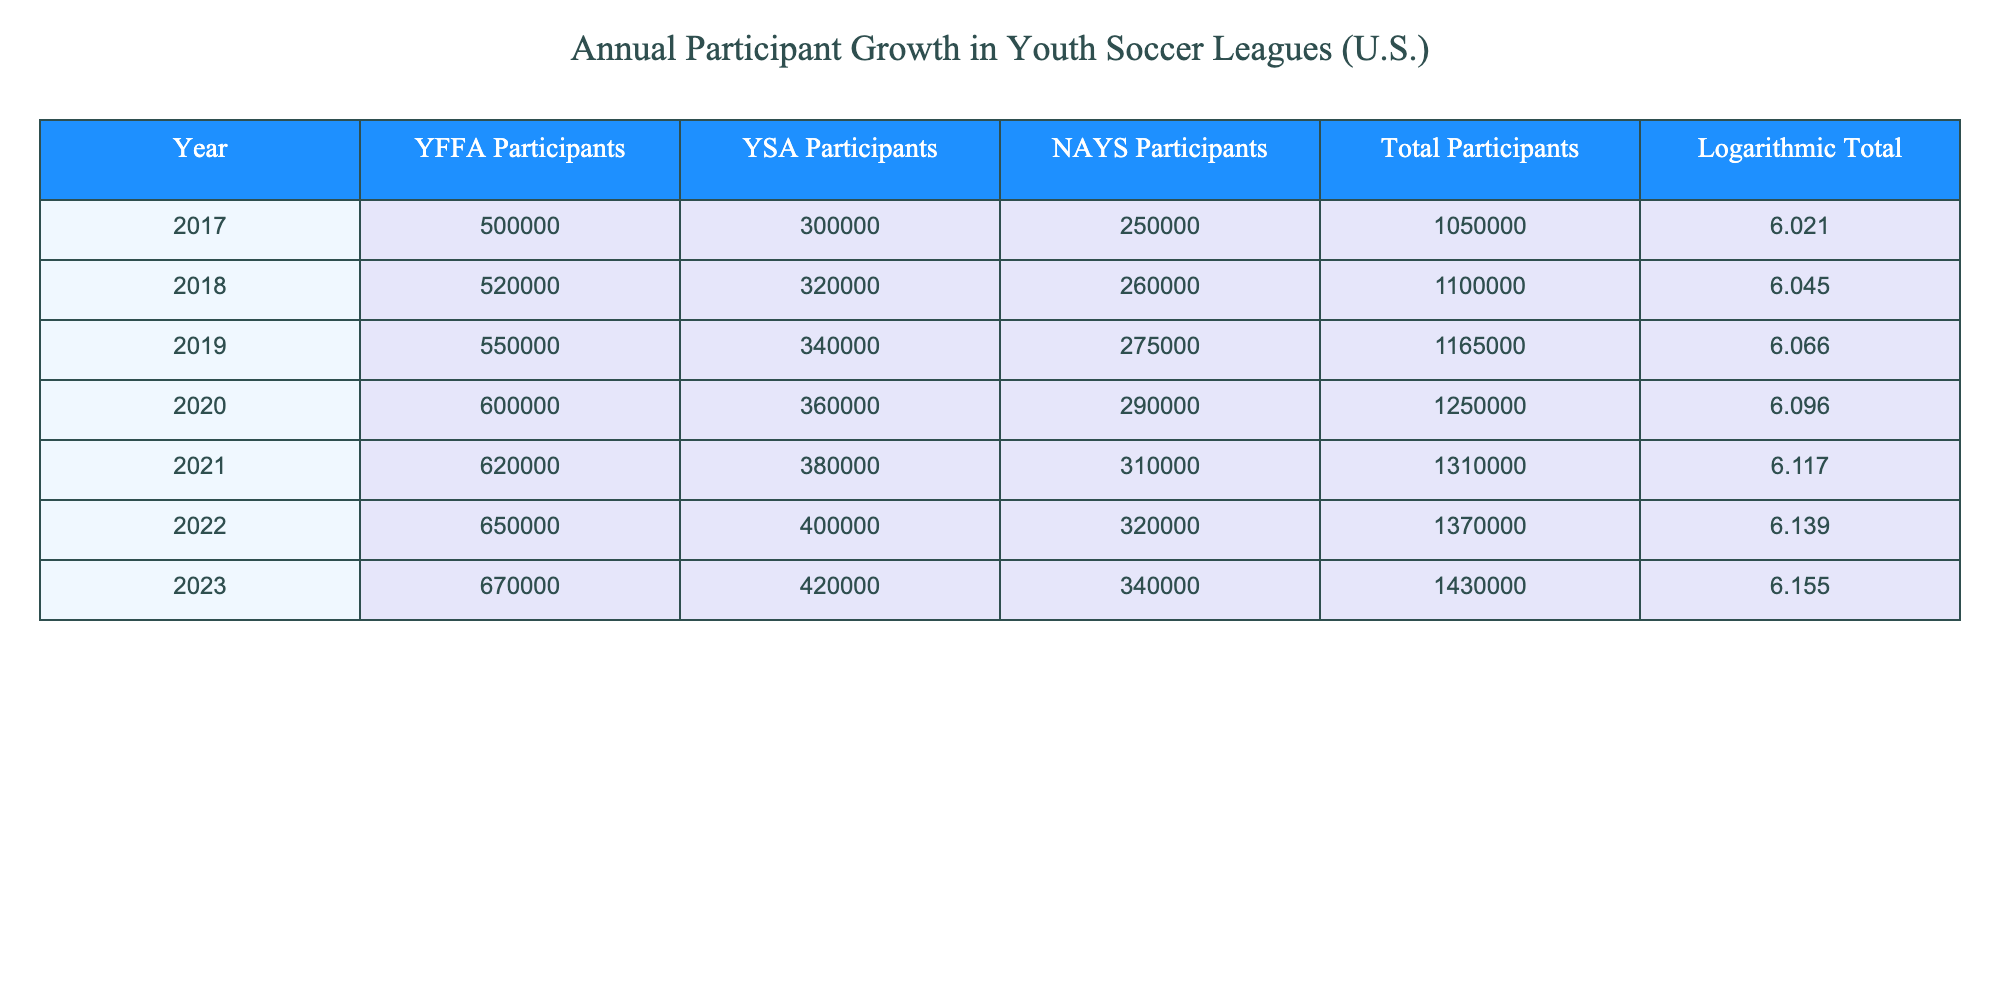What's the total number of participants in 2020? The table lists the total participants for each year. In 2020, the total number of participants is directly given as 1,250,000.
Answer: 1,250,000 What was the increase in total participants from 2017 to 2023? To find the increase, subtract the total participants in 2017 from the total participants in 2023. The calculations: 1,430,000 (2023) - 1,050,000 (2017) = 380,000.
Answer: 380,000 Do the YFFA participants increase every year? By reviewing the YFFA participant values for each year, we can see that they consistently increase: 500,000 in 2017 to 670,000 in 2023, confirming a yearly increase.
Answer: Yes What's the average number of NAYS participants from 2017 to 2023? Calculate the average by summing the NAYS participants across all years and dividing by the total number of years. The sum is 250,000 + 260,000 + 275,000 + 290,000 + 310,000 + 320,000 + 340,000 = 2,045,000. Divide by 7 years: 2,045,000 / 7 = 292,142.86 (rounded to 292,143).
Answer: 292,143 In which year did YSA participants reach 400,000? Looking at the YSA participant values, they reached 400,000 in 2022, as the value listed for that year.
Answer: 2022 What is the yearly growth rate of YFFA participants from 2021 to 2023? The growth from 2021 to 2023 can be calculated by subtracting the 2021 figure from the 2023 figure, then dividing by the 2021 figure and multiplying by 100. Growth = (670,000 - 620,000) / 620,000 * 100 = 8.06%.
Answer: 8.06% Did the total participants decrease at any point from 2017 to 2023? A review of the total participant values shows that they consistently increased from 1,050,000 in 2017 to 1,430,000 in 2023, indicating no decreases occurred in that timeframe.
Answer: No What is the logarithmic value for the total participants in 2021? The table provides a specific logarithmic value for each year's total participants. For 2021, the logarithmic value is 6.117.
Answer: 6.117 